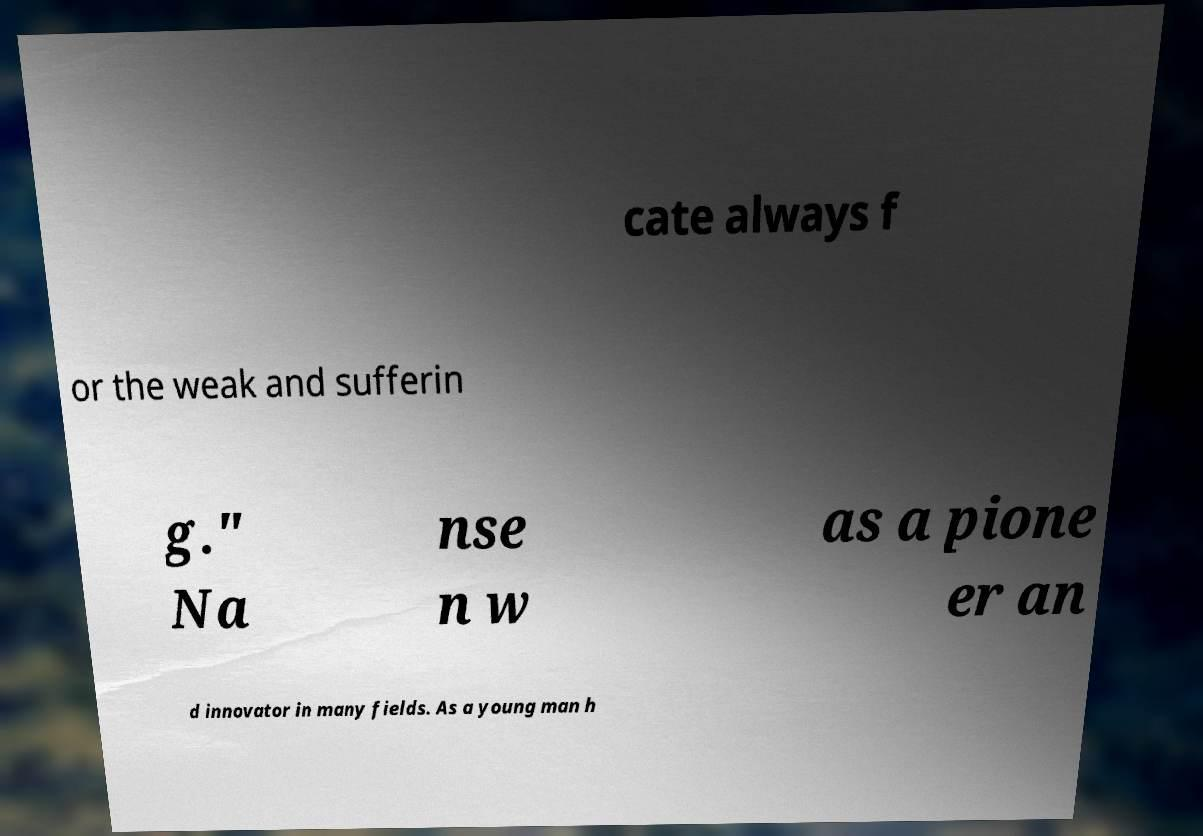For documentation purposes, I need the text within this image transcribed. Could you provide that? cate always f or the weak and sufferin g." Na nse n w as a pione er an d innovator in many fields. As a young man h 